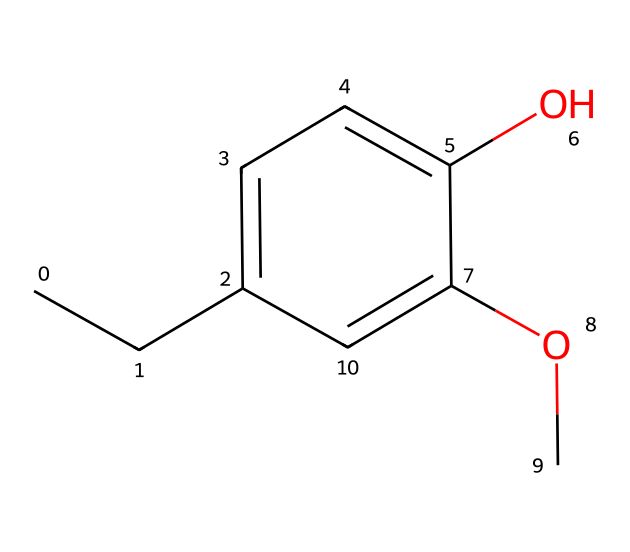What is the total number of carbon atoms in this chemical? The SMILES representation shows a structure with a six-membered aromatic ring and additional carbon atoms attached. Counting the carbons in the ring and the substituents gives a total of eleven carbon atoms.
Answer: eleven How many oxygen atoms are present in this compound? From the SMILES representation, we can identify two oxygen atoms: one in the hydroxyl group (-OH) and another in the methoxy group (-OCH3). Therefore, the total count of oxygen atoms is two.
Answer: two What type of functional group is represented by "-OH" in this chemical? The "-OH" functional group is known as a hydroxyl group, which classifies the compound as an alcohol. Thus, the presence of this group determines the alcohol nature of the compound.
Answer: alcohol Does this chemical contain any aromatic characteristics? The presence of a six-membered carbon ring with alternating double bonds indicates aromatic characteristics, as it fulfills the criteria for aromaticity (planarity, cyclic structure, and resonance).
Answer: yes What is the contribution of eugenol to whiskey flavors? Eugenol contributes spicy and clove-like flavors, which enhance the complexity of certain bourbons by adding depth and warmth to the overall tasting profile.
Answer: spicy flavors Is eugenol considered a natural compound? Eugenol is sourced from natural materials such as clove oil and cinnamon, confirming its classification as a natural compound widely used in flavoring and perfumery.
Answer: yes 